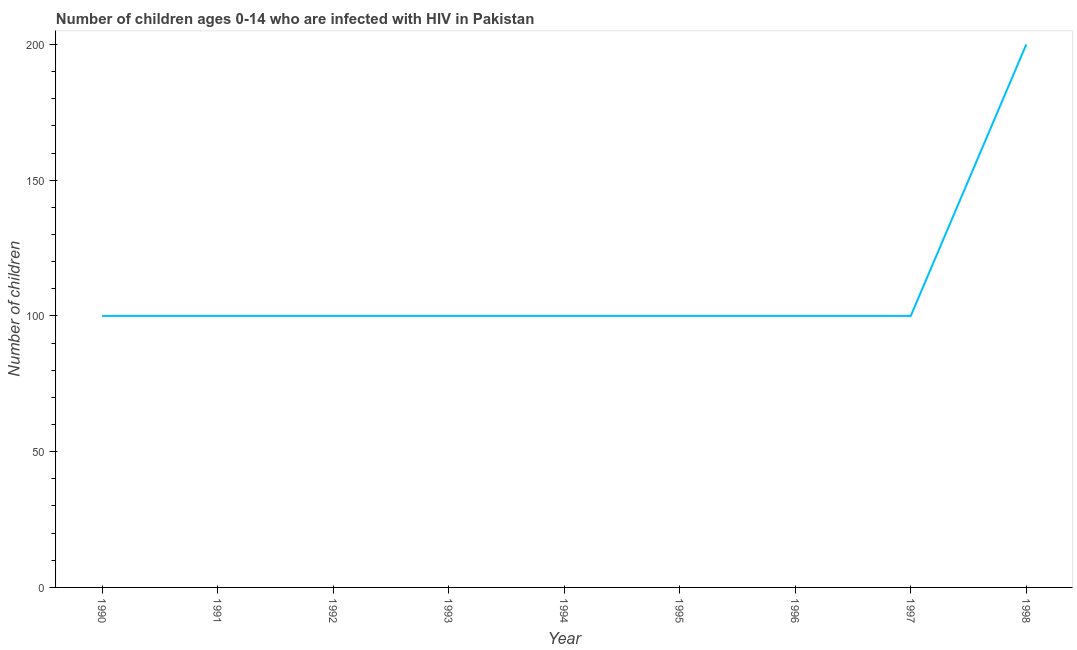What is the number of children living with hiv in 1995?
Your answer should be compact. 100. Across all years, what is the maximum number of children living with hiv?
Offer a terse response. 200. Across all years, what is the minimum number of children living with hiv?
Your answer should be very brief. 100. In which year was the number of children living with hiv maximum?
Offer a terse response. 1998. In which year was the number of children living with hiv minimum?
Ensure brevity in your answer.  1990. What is the sum of the number of children living with hiv?
Keep it short and to the point. 1000. What is the average number of children living with hiv per year?
Keep it short and to the point. 111.11. What is the ratio of the number of children living with hiv in 1991 to that in 1994?
Give a very brief answer. 1. Is the number of children living with hiv in 1991 less than that in 1992?
Ensure brevity in your answer.  No. Is the difference between the number of children living with hiv in 1991 and 1993 greater than the difference between any two years?
Make the answer very short. No. What is the difference between the highest and the lowest number of children living with hiv?
Your answer should be compact. 100. What is the difference between two consecutive major ticks on the Y-axis?
Make the answer very short. 50. Does the graph contain any zero values?
Provide a short and direct response. No. What is the title of the graph?
Offer a terse response. Number of children ages 0-14 who are infected with HIV in Pakistan. What is the label or title of the X-axis?
Your response must be concise. Year. What is the label or title of the Y-axis?
Your answer should be very brief. Number of children. What is the Number of children of 1990?
Provide a short and direct response. 100. What is the Number of children in 1993?
Offer a very short reply. 100. What is the Number of children of 1994?
Ensure brevity in your answer.  100. What is the difference between the Number of children in 1990 and 1993?
Your response must be concise. 0. What is the difference between the Number of children in 1990 and 1995?
Give a very brief answer. 0. What is the difference between the Number of children in 1990 and 1998?
Give a very brief answer. -100. What is the difference between the Number of children in 1991 and 1994?
Offer a terse response. 0. What is the difference between the Number of children in 1991 and 1998?
Give a very brief answer. -100. What is the difference between the Number of children in 1992 and 1998?
Give a very brief answer. -100. What is the difference between the Number of children in 1993 and 1995?
Keep it short and to the point. 0. What is the difference between the Number of children in 1993 and 1997?
Ensure brevity in your answer.  0. What is the difference between the Number of children in 1993 and 1998?
Keep it short and to the point. -100. What is the difference between the Number of children in 1994 and 1995?
Your response must be concise. 0. What is the difference between the Number of children in 1994 and 1998?
Make the answer very short. -100. What is the difference between the Number of children in 1995 and 1997?
Provide a succinct answer. 0. What is the difference between the Number of children in 1995 and 1998?
Ensure brevity in your answer.  -100. What is the difference between the Number of children in 1996 and 1997?
Make the answer very short. 0. What is the difference between the Number of children in 1996 and 1998?
Provide a succinct answer. -100. What is the difference between the Number of children in 1997 and 1998?
Keep it short and to the point. -100. What is the ratio of the Number of children in 1990 to that in 1992?
Offer a very short reply. 1. What is the ratio of the Number of children in 1990 to that in 1994?
Your answer should be compact. 1. What is the ratio of the Number of children in 1990 to that in 1996?
Your answer should be compact. 1. What is the ratio of the Number of children in 1990 to that in 1998?
Give a very brief answer. 0.5. What is the ratio of the Number of children in 1991 to that in 1992?
Give a very brief answer. 1. What is the ratio of the Number of children in 1991 to that in 1995?
Your answer should be compact. 1. What is the ratio of the Number of children in 1991 to that in 1996?
Your response must be concise. 1. What is the ratio of the Number of children in 1992 to that in 1996?
Your response must be concise. 1. What is the ratio of the Number of children in 1993 to that in 1994?
Give a very brief answer. 1. What is the ratio of the Number of children in 1993 to that in 1995?
Keep it short and to the point. 1. What is the ratio of the Number of children in 1994 to that in 1995?
Ensure brevity in your answer.  1. What is the ratio of the Number of children in 1994 to that in 1997?
Provide a short and direct response. 1. What is the ratio of the Number of children in 1995 to that in 1996?
Provide a short and direct response. 1. 